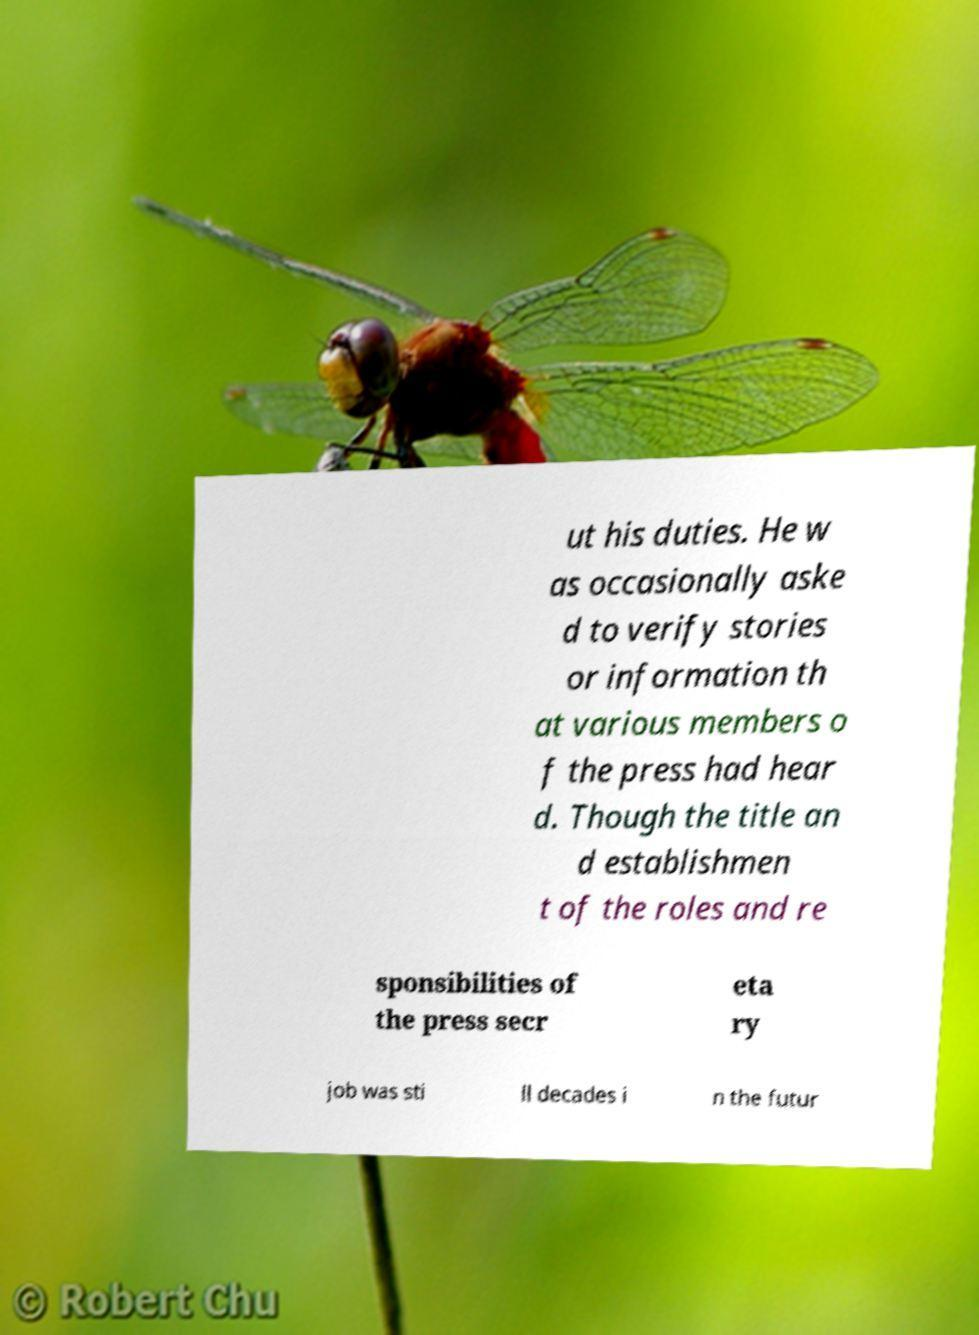Can you accurately transcribe the text from the provided image for me? ut his duties. He w as occasionally aske d to verify stories or information th at various members o f the press had hear d. Though the title an d establishmen t of the roles and re sponsibilities of the press secr eta ry job was sti ll decades i n the futur 